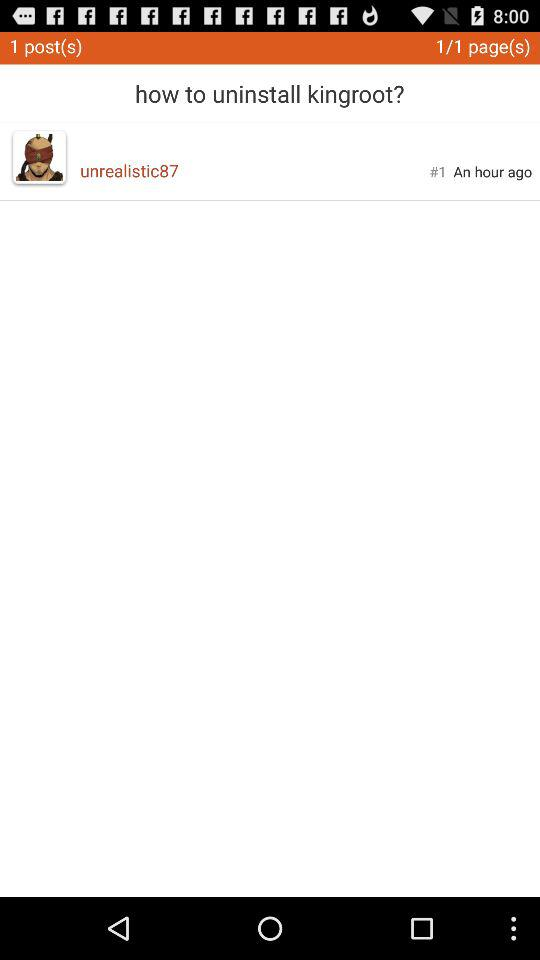How many posts are there in the forum?
Answer the question using a single word or phrase. 1 